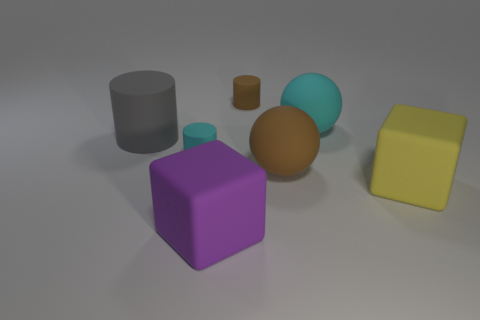Subtract all small brown cylinders. How many cylinders are left? 2 Add 1 brown objects. How many objects exist? 8 Subtract all balls. How many objects are left? 5 Add 2 tiny rubber cylinders. How many tiny rubber cylinders exist? 4 Subtract 0 purple spheres. How many objects are left? 7 Subtract all cyan balls. Subtract all green cylinders. How many balls are left? 1 Subtract all tiny brown matte cylinders. Subtract all yellow rubber cubes. How many objects are left? 5 Add 5 big yellow objects. How many big yellow objects are left? 6 